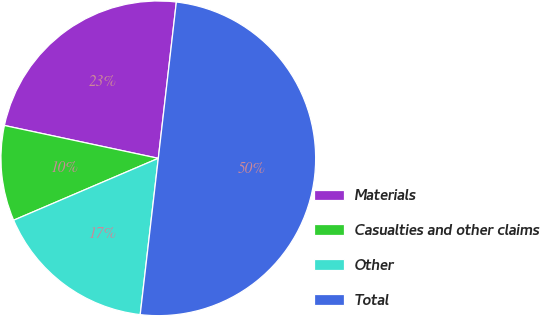<chart> <loc_0><loc_0><loc_500><loc_500><pie_chart><fcel>Materials<fcel>Casualties and other claims<fcel>Other<fcel>Total<nl><fcel>23.48%<fcel>9.78%<fcel>16.73%<fcel>50.0%<nl></chart> 